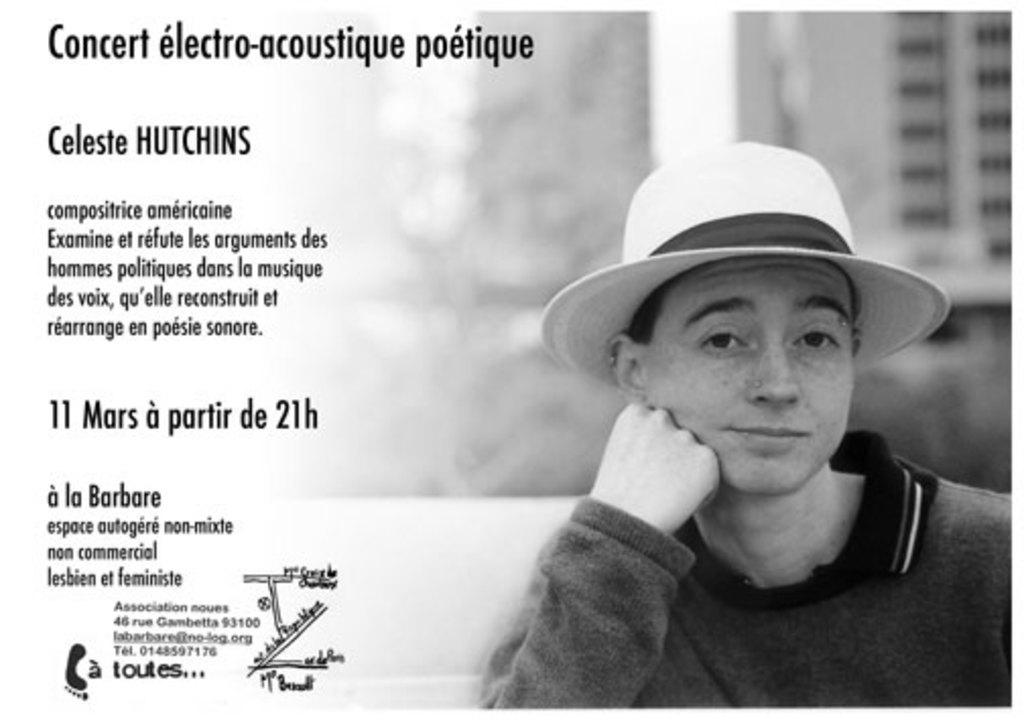What is the person in the image wearing on their head? The person in the image is wearing a hat. What can be observed about the background of the image? The background of the image is blurred. What elements are present on the left side of the image? There are numbers, text, and a logo on the left side of the image. What type of stove is used to cook the person's belief in the image? There is no stove or cooking activity present in the image, nor is there any mention of a belief. 